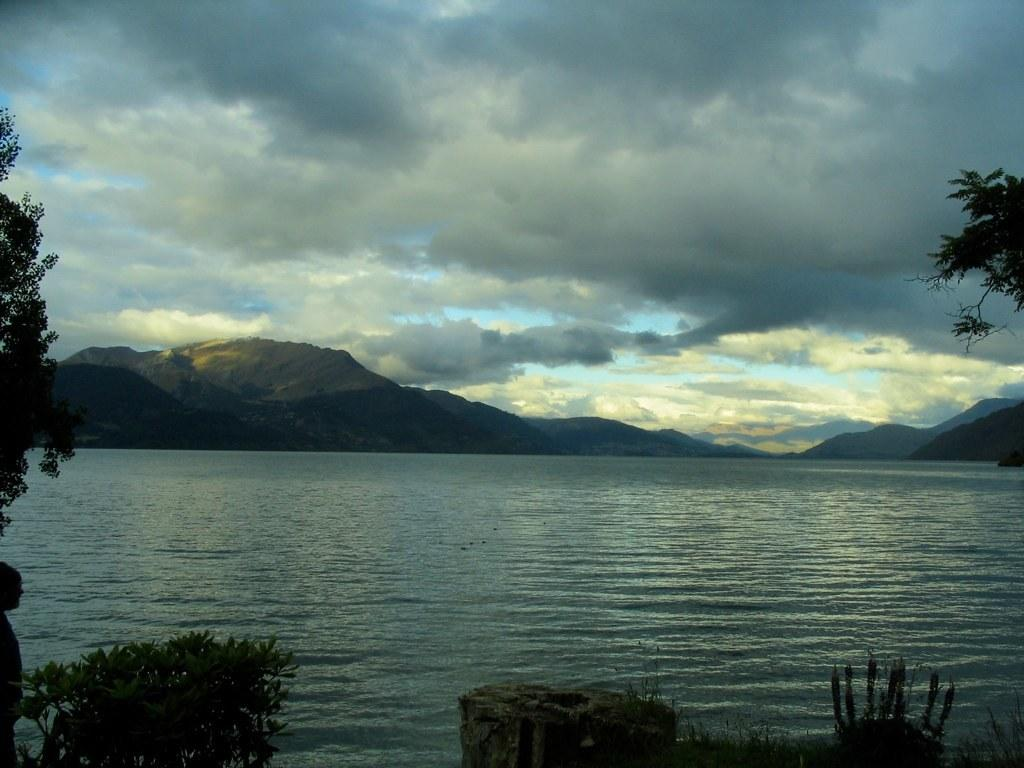What is the main subject of the image? The image depicts a river. What can be seen in the foreground of the image? There are trees in the foreground. What is visible in the background of the image? There are mountains in the background. What is visible at the top of the image? The sky is visible at the top of the image. What can be seen in the sky? There are clouds in the sky. What is present at the bottom of the image? Water is present at the bottom of the image. How many bananas are hanging from the trees in the image? There are no bananas present in the image; it features a river with trees and mountains in the background. What type of bean is growing near the river in the image? There are no beans present in the image; it features a river with trees and mountains in the background. 